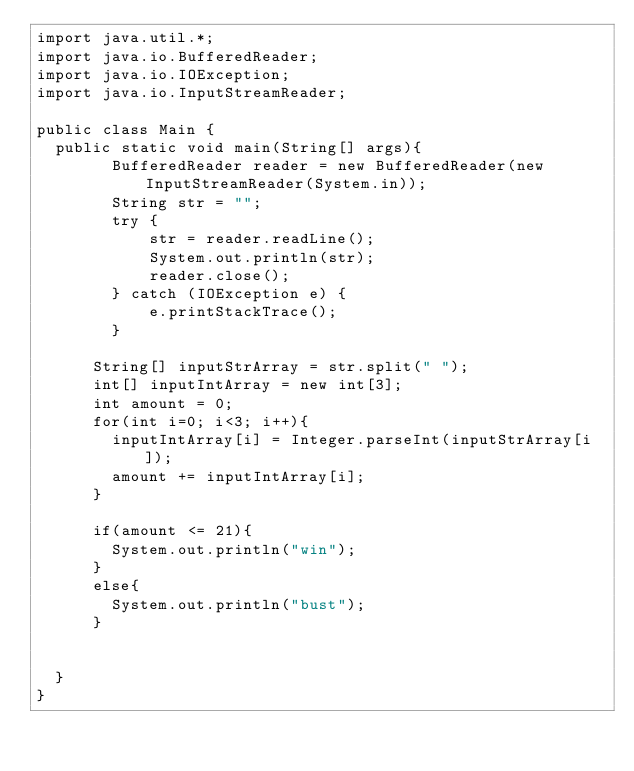Convert code to text. <code><loc_0><loc_0><loc_500><loc_500><_Java_>import java.util.*;
import java.io.BufferedReader;
import java.io.IOException;
import java.io.InputStreamReader;

public class Main {
	public static void main(String[] args){
        BufferedReader reader = new BufferedReader(new InputStreamReader(System.in));
        String str = "";
        try {
            str = reader.readLine();
            System.out.println(str);
            reader.close();
        } catch (IOException e) {
            e.printStackTrace();
        }
      
      String[] inputStrArray = str.split(" ");
      int[] inputIntArray = new int[3];
      int amount = 0;
      for(int i=0; i<3; i++){
        inputIntArray[i] = Integer.parseInt(inputStrArray[i]);
        amount += inputIntArray[i];
      }
      
      if(amount <= 21){
        System.out.println("win");
      }
      else{
        System.out.println("bust"); 
      }
      
      
	}
}</code> 